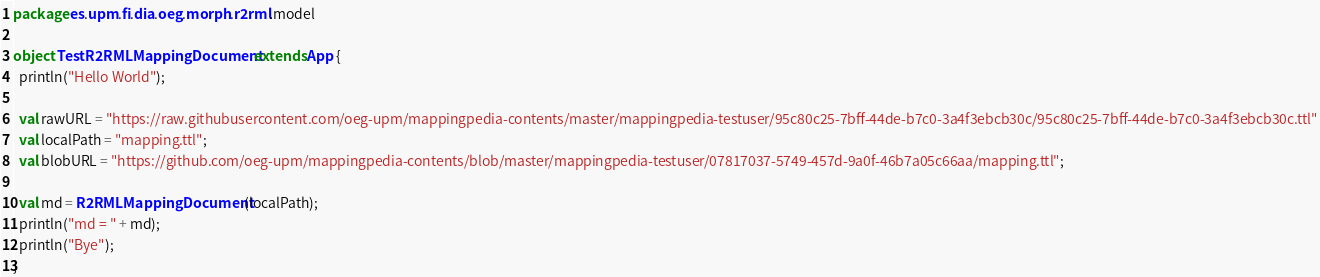Convert code to text. <code><loc_0><loc_0><loc_500><loc_500><_Scala_>package es.upm.fi.dia.oeg.morph.r2rml.model

object TestR2RMLMappingDocument extends App {
  println("Hello World");
  
  val rawURL = "https://raw.githubusercontent.com/oeg-upm/mappingpedia-contents/master/mappingpedia-testuser/95c80c25-7bff-44de-b7c0-3a4f3ebcb30c/95c80c25-7bff-44de-b7c0-3a4f3ebcb30c.ttl"
  val localPath = "mapping.ttl";
  val blobURL = "https://github.com/oeg-upm/mappingpedia-contents/blob/master/mappingpedia-testuser/07817037-5749-457d-9a0f-46b7a05c66aa/mapping.ttl";
  
  val md = R2RMLMappingDocument(localPath);
  println("md = " + md);
  println("Bye");
}

</code> 